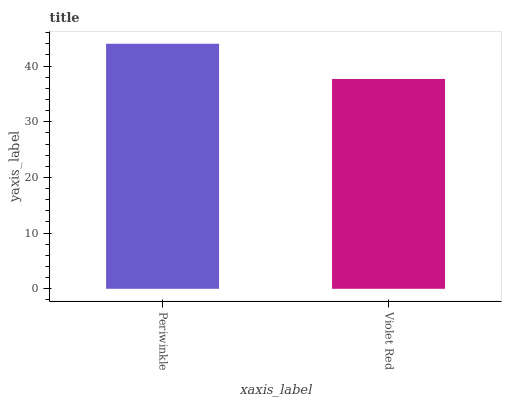Is Violet Red the minimum?
Answer yes or no. Yes. Is Periwinkle the maximum?
Answer yes or no. Yes. Is Violet Red the maximum?
Answer yes or no. No. Is Periwinkle greater than Violet Red?
Answer yes or no. Yes. Is Violet Red less than Periwinkle?
Answer yes or no. Yes. Is Violet Red greater than Periwinkle?
Answer yes or no. No. Is Periwinkle less than Violet Red?
Answer yes or no. No. Is Periwinkle the high median?
Answer yes or no. Yes. Is Violet Red the low median?
Answer yes or no. Yes. Is Violet Red the high median?
Answer yes or no. No. Is Periwinkle the low median?
Answer yes or no. No. 